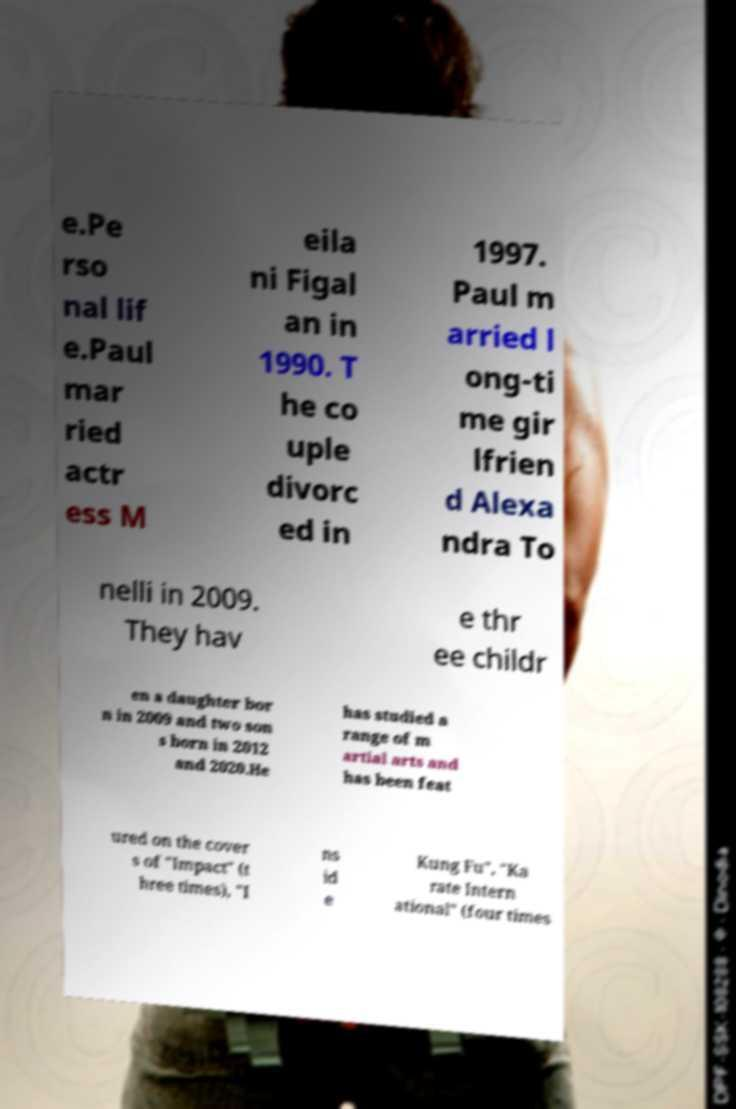Could you extract and type out the text from this image? e.Pe rso nal lif e.Paul mar ried actr ess M eila ni Figal an in 1990. T he co uple divorc ed in 1997. Paul m arried l ong-ti me gir lfrien d Alexa ndra To nelli in 2009. They hav e thr ee childr en a daughter bor n in 2009 and two son s born in 2012 and 2020.He has studied a range of m artial arts and has been feat ured on the cover s of "Impact" (t hree times), "I ns id e Kung Fu", "Ka rate Intern ational" (four times 